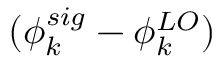Convert formula to latex. <formula><loc_0><loc_0><loc_500><loc_500>( \phi _ { k } ^ { s i g } - \phi _ { k } ^ { L O } )</formula> 